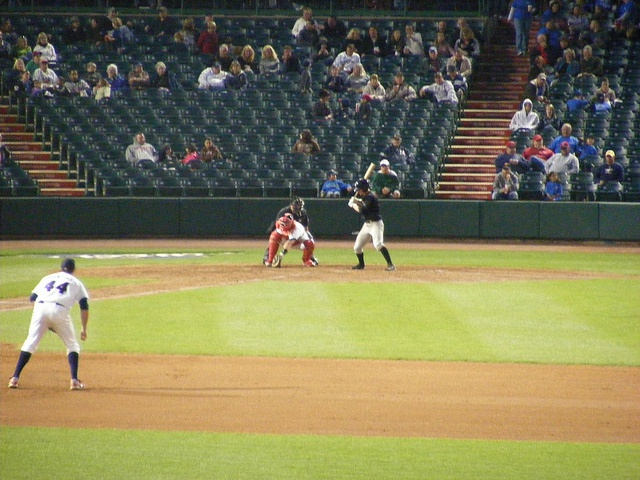Describe the objects in this image and their specific colors. I can see people in black, gray, navy, and darkgray tones, people in black, white, darkgray, and tan tones, people in black, ivory, gray, and darkgray tones, people in black, brown, white, lightpink, and maroon tones, and people in black, navy, gray, and darkblue tones in this image. 